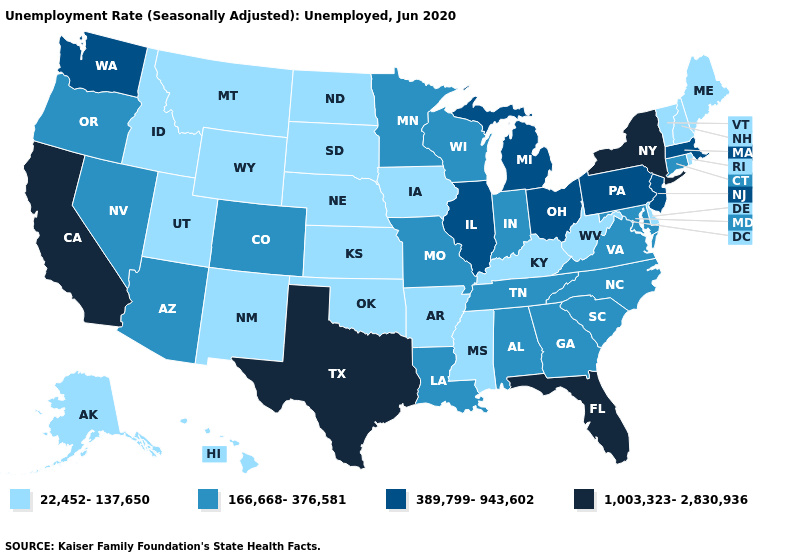Name the states that have a value in the range 22,452-137,650?
Write a very short answer. Alaska, Arkansas, Delaware, Hawaii, Idaho, Iowa, Kansas, Kentucky, Maine, Mississippi, Montana, Nebraska, New Hampshire, New Mexico, North Dakota, Oklahoma, Rhode Island, South Dakota, Utah, Vermont, West Virginia, Wyoming. Name the states that have a value in the range 166,668-376,581?
Concise answer only. Alabama, Arizona, Colorado, Connecticut, Georgia, Indiana, Louisiana, Maryland, Minnesota, Missouri, Nevada, North Carolina, Oregon, South Carolina, Tennessee, Virginia, Wisconsin. Which states have the lowest value in the West?
Give a very brief answer. Alaska, Hawaii, Idaho, Montana, New Mexico, Utah, Wyoming. Is the legend a continuous bar?
Write a very short answer. No. Does Virginia have a higher value than North Dakota?
Give a very brief answer. Yes. Is the legend a continuous bar?
Keep it brief. No. Name the states that have a value in the range 389,799-943,602?
Quick response, please. Illinois, Massachusetts, Michigan, New Jersey, Ohio, Pennsylvania, Washington. What is the value of California?
Answer briefly. 1,003,323-2,830,936. Name the states that have a value in the range 1,003,323-2,830,936?
Answer briefly. California, Florida, New York, Texas. What is the value of Iowa?
Keep it brief. 22,452-137,650. Does Alaska have the lowest value in the West?
Answer briefly. Yes. What is the lowest value in states that border Missouri?
Answer briefly. 22,452-137,650. What is the highest value in the MidWest ?
Be succinct. 389,799-943,602. Name the states that have a value in the range 389,799-943,602?
Write a very short answer. Illinois, Massachusetts, Michigan, New Jersey, Ohio, Pennsylvania, Washington. 